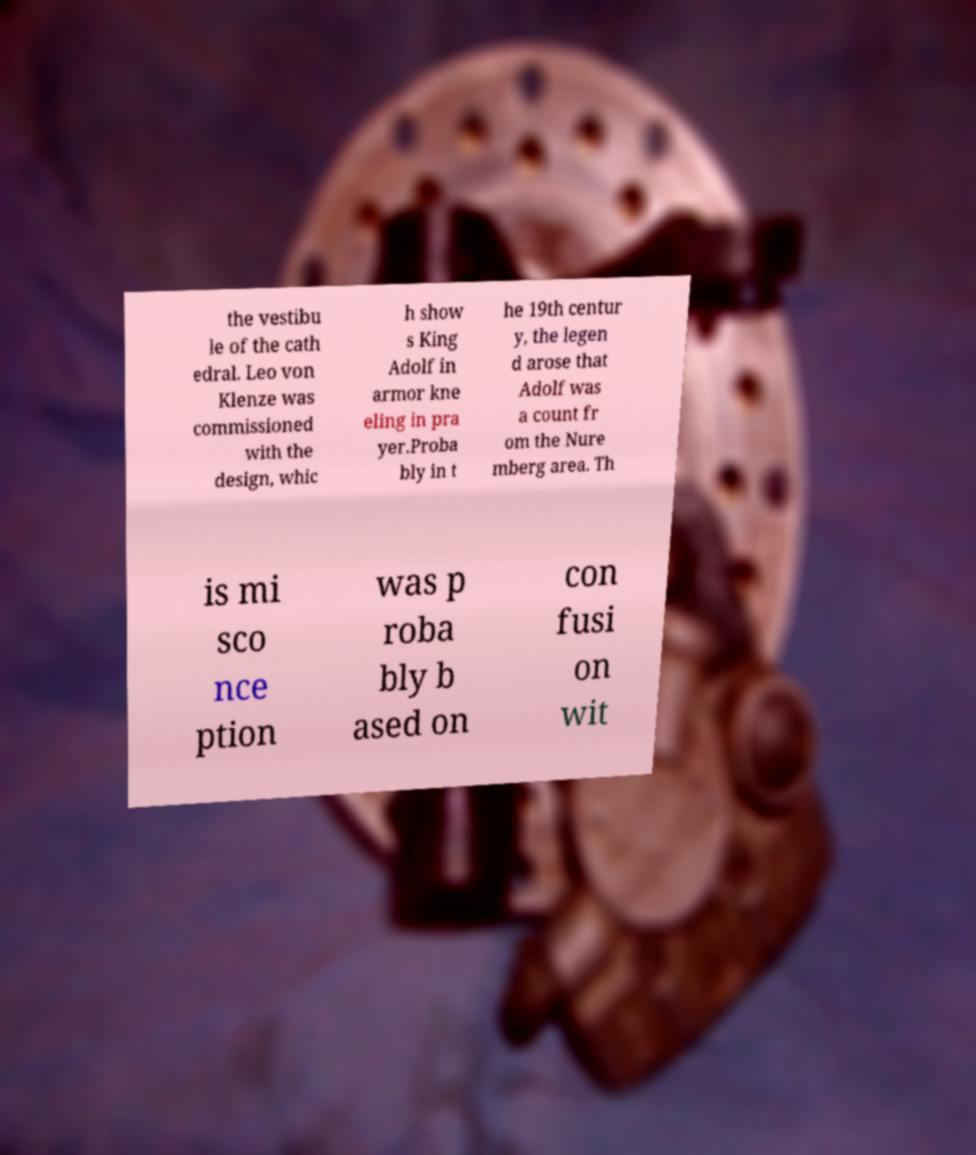Can you read and provide the text displayed in the image?This photo seems to have some interesting text. Can you extract and type it out for me? the vestibu le of the cath edral. Leo von Klenze was commissioned with the design, whic h show s King Adolf in armor kne eling in pra yer.Proba bly in t he 19th centur y, the legen d arose that Adolf was a count fr om the Nure mberg area. Th is mi sco nce ption was p roba bly b ased on con fusi on wit 